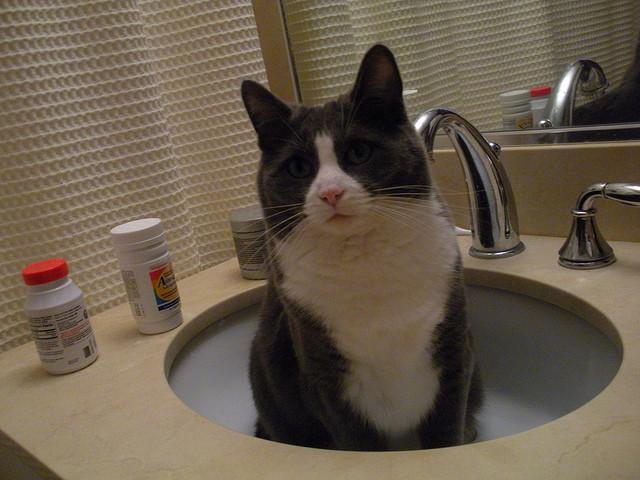What color is the countertops?
Give a very brief answer. Brown. Where is the cat in this photo?
Keep it brief. Sink. Is the cat wet yet?
Write a very short answer. No. What color is the faucet handle?
Concise answer only. Silver. 